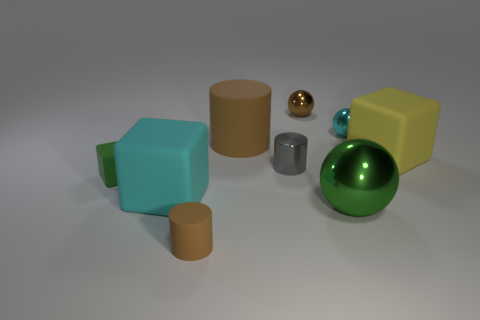What number of matte objects are large cyan cubes or small green objects?
Provide a succinct answer. 2. There is a tiny brown object that is behind the rubber cylinder that is behind the metal cylinder; how many cylinders are to the left of it?
Give a very brief answer. 3. Does the green object that is on the right side of the brown metallic thing have the same size as the shiny ball behind the small cyan shiny thing?
Your answer should be very brief. No. What material is the other brown object that is the same shape as the large metal object?
Provide a short and direct response. Metal. What number of small things are either brown metal blocks or brown spheres?
Provide a short and direct response. 1. What material is the green block?
Keep it short and to the point. Rubber. There is a object that is to the right of the small gray metal object and in front of the large cyan block; what material is it made of?
Provide a succinct answer. Metal. Do the large sphere and the tiny matte object on the left side of the tiny matte cylinder have the same color?
Your answer should be very brief. Yes. What material is the gray thing that is the same size as the green matte thing?
Offer a very short reply. Metal. Is there a small green thing made of the same material as the green ball?
Offer a very short reply. No. 